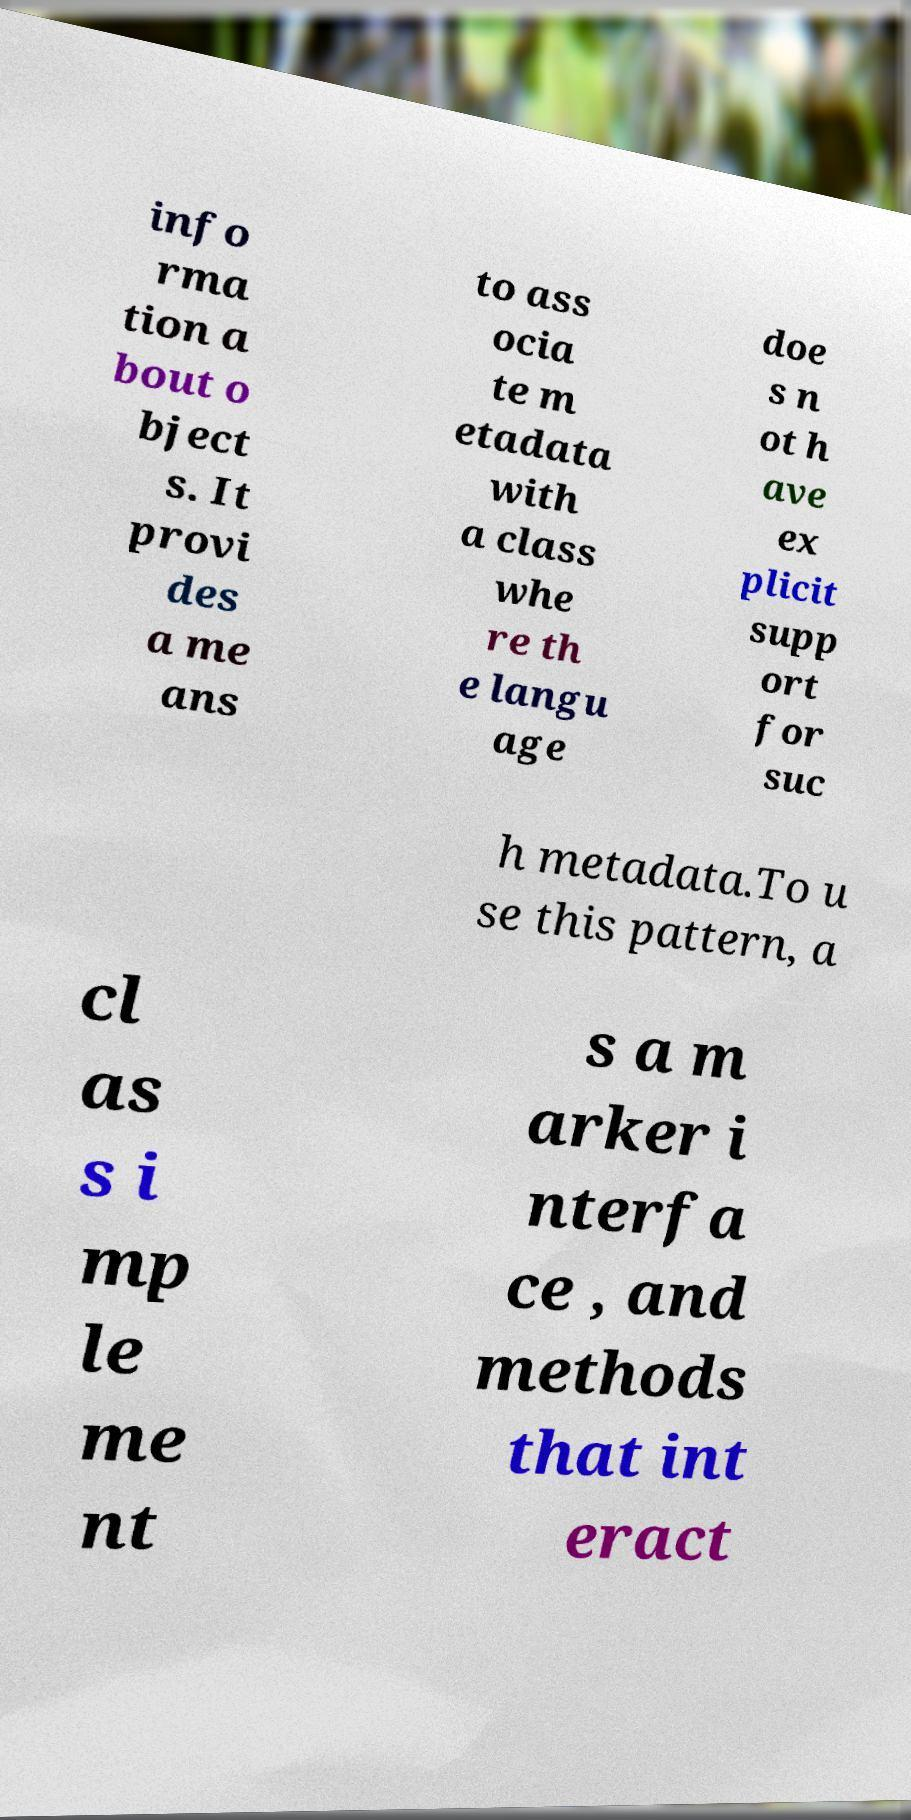What messages or text are displayed in this image? I need them in a readable, typed format. info rma tion a bout o bject s. It provi des a me ans to ass ocia te m etadata with a class whe re th e langu age doe s n ot h ave ex plicit supp ort for suc h metadata.To u se this pattern, a cl as s i mp le me nt s a m arker i nterfa ce , and methods that int eract 